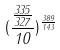<formula> <loc_0><loc_0><loc_500><loc_500>( \frac { \frac { 3 3 5 } { 3 2 7 } } { 1 0 } ) ^ { \frac { 3 8 9 } { 1 4 3 } }</formula> 